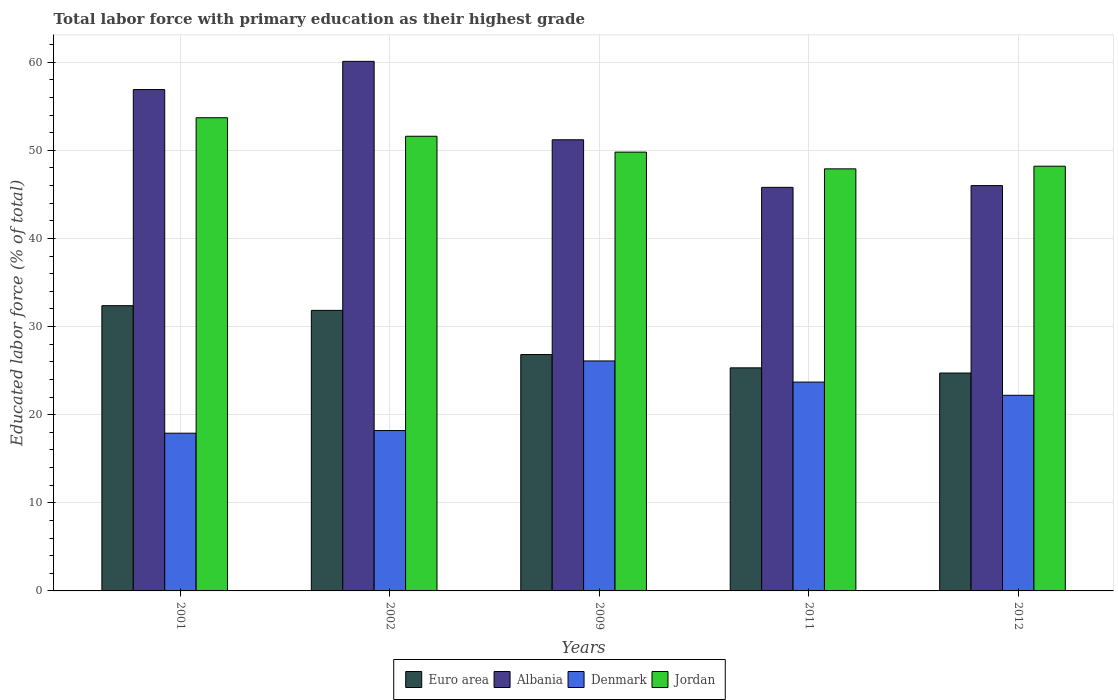How many different coloured bars are there?
Give a very brief answer. 4. How many groups of bars are there?
Your response must be concise. 5. Are the number of bars per tick equal to the number of legend labels?
Make the answer very short. Yes. Are the number of bars on each tick of the X-axis equal?
Provide a short and direct response. Yes. How many bars are there on the 1st tick from the left?
Keep it short and to the point. 4. In how many cases, is the number of bars for a given year not equal to the number of legend labels?
Offer a very short reply. 0. What is the percentage of total labor force with primary education in Albania in 2002?
Your response must be concise. 60.1. Across all years, what is the maximum percentage of total labor force with primary education in Denmark?
Make the answer very short. 26.1. Across all years, what is the minimum percentage of total labor force with primary education in Denmark?
Make the answer very short. 17.9. In which year was the percentage of total labor force with primary education in Euro area maximum?
Provide a succinct answer. 2001. In which year was the percentage of total labor force with primary education in Denmark minimum?
Your answer should be compact. 2001. What is the total percentage of total labor force with primary education in Jordan in the graph?
Offer a very short reply. 251.2. What is the difference between the percentage of total labor force with primary education in Albania in 2001 and that in 2012?
Make the answer very short. 10.9. What is the difference between the percentage of total labor force with primary education in Jordan in 2009 and the percentage of total labor force with primary education in Albania in 2002?
Provide a short and direct response. -10.3. What is the average percentage of total labor force with primary education in Denmark per year?
Offer a very short reply. 21.62. In the year 2011, what is the difference between the percentage of total labor force with primary education in Albania and percentage of total labor force with primary education in Denmark?
Provide a succinct answer. 22.1. What is the ratio of the percentage of total labor force with primary education in Euro area in 2002 to that in 2009?
Offer a terse response. 1.19. What is the difference between the highest and the second highest percentage of total labor force with primary education in Albania?
Your answer should be very brief. 3.2. What is the difference between the highest and the lowest percentage of total labor force with primary education in Albania?
Make the answer very short. 14.3. Is the sum of the percentage of total labor force with primary education in Denmark in 2011 and 2012 greater than the maximum percentage of total labor force with primary education in Euro area across all years?
Your response must be concise. Yes. What does the 2nd bar from the left in 2011 represents?
Ensure brevity in your answer.  Albania. What does the 2nd bar from the right in 2002 represents?
Your response must be concise. Denmark. Are all the bars in the graph horizontal?
Offer a terse response. No. Does the graph contain grids?
Ensure brevity in your answer.  Yes. How are the legend labels stacked?
Keep it short and to the point. Horizontal. What is the title of the graph?
Offer a very short reply. Total labor force with primary education as their highest grade. What is the label or title of the Y-axis?
Your answer should be very brief. Educated labor force (% of total). What is the Educated labor force (% of total) in Euro area in 2001?
Make the answer very short. 32.37. What is the Educated labor force (% of total) in Albania in 2001?
Ensure brevity in your answer.  56.9. What is the Educated labor force (% of total) in Denmark in 2001?
Offer a very short reply. 17.9. What is the Educated labor force (% of total) of Jordan in 2001?
Your answer should be very brief. 53.7. What is the Educated labor force (% of total) of Euro area in 2002?
Make the answer very short. 31.84. What is the Educated labor force (% of total) of Albania in 2002?
Provide a succinct answer. 60.1. What is the Educated labor force (% of total) of Denmark in 2002?
Keep it short and to the point. 18.2. What is the Educated labor force (% of total) in Jordan in 2002?
Ensure brevity in your answer.  51.6. What is the Educated labor force (% of total) in Euro area in 2009?
Give a very brief answer. 26.83. What is the Educated labor force (% of total) of Albania in 2009?
Provide a short and direct response. 51.2. What is the Educated labor force (% of total) in Denmark in 2009?
Ensure brevity in your answer.  26.1. What is the Educated labor force (% of total) of Jordan in 2009?
Provide a succinct answer. 49.8. What is the Educated labor force (% of total) of Euro area in 2011?
Keep it short and to the point. 25.32. What is the Educated labor force (% of total) of Albania in 2011?
Provide a succinct answer. 45.8. What is the Educated labor force (% of total) of Denmark in 2011?
Your answer should be compact. 23.7. What is the Educated labor force (% of total) of Jordan in 2011?
Provide a succinct answer. 47.9. What is the Educated labor force (% of total) of Euro area in 2012?
Make the answer very short. 24.73. What is the Educated labor force (% of total) of Albania in 2012?
Your response must be concise. 46. What is the Educated labor force (% of total) in Denmark in 2012?
Your response must be concise. 22.2. What is the Educated labor force (% of total) of Jordan in 2012?
Provide a short and direct response. 48.2. Across all years, what is the maximum Educated labor force (% of total) in Euro area?
Ensure brevity in your answer.  32.37. Across all years, what is the maximum Educated labor force (% of total) of Albania?
Your answer should be very brief. 60.1. Across all years, what is the maximum Educated labor force (% of total) in Denmark?
Provide a short and direct response. 26.1. Across all years, what is the maximum Educated labor force (% of total) in Jordan?
Ensure brevity in your answer.  53.7. Across all years, what is the minimum Educated labor force (% of total) of Euro area?
Your response must be concise. 24.73. Across all years, what is the minimum Educated labor force (% of total) of Albania?
Make the answer very short. 45.8. Across all years, what is the minimum Educated labor force (% of total) in Denmark?
Provide a succinct answer. 17.9. Across all years, what is the minimum Educated labor force (% of total) of Jordan?
Your response must be concise. 47.9. What is the total Educated labor force (% of total) of Euro area in the graph?
Offer a very short reply. 141.08. What is the total Educated labor force (% of total) in Albania in the graph?
Keep it short and to the point. 260. What is the total Educated labor force (% of total) in Denmark in the graph?
Offer a very short reply. 108.1. What is the total Educated labor force (% of total) of Jordan in the graph?
Your response must be concise. 251.2. What is the difference between the Educated labor force (% of total) in Euro area in 2001 and that in 2002?
Provide a short and direct response. 0.53. What is the difference between the Educated labor force (% of total) of Albania in 2001 and that in 2002?
Your answer should be very brief. -3.2. What is the difference between the Educated labor force (% of total) of Jordan in 2001 and that in 2002?
Offer a terse response. 2.1. What is the difference between the Educated labor force (% of total) in Euro area in 2001 and that in 2009?
Provide a succinct answer. 5.55. What is the difference between the Educated labor force (% of total) in Euro area in 2001 and that in 2011?
Your response must be concise. 7.05. What is the difference between the Educated labor force (% of total) of Denmark in 2001 and that in 2011?
Offer a terse response. -5.8. What is the difference between the Educated labor force (% of total) in Jordan in 2001 and that in 2011?
Offer a terse response. 5.8. What is the difference between the Educated labor force (% of total) in Euro area in 2001 and that in 2012?
Make the answer very short. 7.64. What is the difference between the Educated labor force (% of total) of Denmark in 2001 and that in 2012?
Give a very brief answer. -4.3. What is the difference between the Educated labor force (% of total) of Jordan in 2001 and that in 2012?
Your answer should be compact. 5.5. What is the difference between the Educated labor force (% of total) in Euro area in 2002 and that in 2009?
Give a very brief answer. 5.01. What is the difference between the Educated labor force (% of total) in Denmark in 2002 and that in 2009?
Your answer should be compact. -7.9. What is the difference between the Educated labor force (% of total) in Euro area in 2002 and that in 2011?
Offer a very short reply. 6.52. What is the difference between the Educated labor force (% of total) in Jordan in 2002 and that in 2011?
Keep it short and to the point. 3.7. What is the difference between the Educated labor force (% of total) in Euro area in 2002 and that in 2012?
Provide a short and direct response. 7.11. What is the difference between the Educated labor force (% of total) in Albania in 2002 and that in 2012?
Keep it short and to the point. 14.1. What is the difference between the Educated labor force (% of total) of Euro area in 2009 and that in 2011?
Make the answer very short. 1.51. What is the difference between the Educated labor force (% of total) in Jordan in 2009 and that in 2011?
Your response must be concise. 1.9. What is the difference between the Educated labor force (% of total) in Euro area in 2009 and that in 2012?
Your answer should be very brief. 2.1. What is the difference between the Educated labor force (% of total) of Albania in 2009 and that in 2012?
Your answer should be very brief. 5.2. What is the difference between the Educated labor force (% of total) of Euro area in 2011 and that in 2012?
Your answer should be compact. 0.59. What is the difference between the Educated labor force (% of total) of Albania in 2011 and that in 2012?
Offer a terse response. -0.2. What is the difference between the Educated labor force (% of total) in Denmark in 2011 and that in 2012?
Give a very brief answer. 1.5. What is the difference between the Educated labor force (% of total) in Jordan in 2011 and that in 2012?
Keep it short and to the point. -0.3. What is the difference between the Educated labor force (% of total) of Euro area in 2001 and the Educated labor force (% of total) of Albania in 2002?
Give a very brief answer. -27.73. What is the difference between the Educated labor force (% of total) of Euro area in 2001 and the Educated labor force (% of total) of Denmark in 2002?
Ensure brevity in your answer.  14.17. What is the difference between the Educated labor force (% of total) in Euro area in 2001 and the Educated labor force (% of total) in Jordan in 2002?
Keep it short and to the point. -19.23. What is the difference between the Educated labor force (% of total) of Albania in 2001 and the Educated labor force (% of total) of Denmark in 2002?
Keep it short and to the point. 38.7. What is the difference between the Educated labor force (% of total) in Albania in 2001 and the Educated labor force (% of total) in Jordan in 2002?
Offer a very short reply. 5.3. What is the difference between the Educated labor force (% of total) of Denmark in 2001 and the Educated labor force (% of total) of Jordan in 2002?
Your answer should be very brief. -33.7. What is the difference between the Educated labor force (% of total) of Euro area in 2001 and the Educated labor force (% of total) of Albania in 2009?
Keep it short and to the point. -18.83. What is the difference between the Educated labor force (% of total) in Euro area in 2001 and the Educated labor force (% of total) in Denmark in 2009?
Your response must be concise. 6.27. What is the difference between the Educated labor force (% of total) in Euro area in 2001 and the Educated labor force (% of total) in Jordan in 2009?
Ensure brevity in your answer.  -17.43. What is the difference between the Educated labor force (% of total) in Albania in 2001 and the Educated labor force (% of total) in Denmark in 2009?
Your answer should be compact. 30.8. What is the difference between the Educated labor force (% of total) in Denmark in 2001 and the Educated labor force (% of total) in Jordan in 2009?
Ensure brevity in your answer.  -31.9. What is the difference between the Educated labor force (% of total) of Euro area in 2001 and the Educated labor force (% of total) of Albania in 2011?
Ensure brevity in your answer.  -13.43. What is the difference between the Educated labor force (% of total) of Euro area in 2001 and the Educated labor force (% of total) of Denmark in 2011?
Your answer should be very brief. 8.67. What is the difference between the Educated labor force (% of total) in Euro area in 2001 and the Educated labor force (% of total) in Jordan in 2011?
Give a very brief answer. -15.53. What is the difference between the Educated labor force (% of total) in Albania in 2001 and the Educated labor force (% of total) in Denmark in 2011?
Provide a succinct answer. 33.2. What is the difference between the Educated labor force (% of total) of Albania in 2001 and the Educated labor force (% of total) of Jordan in 2011?
Keep it short and to the point. 9. What is the difference between the Educated labor force (% of total) in Denmark in 2001 and the Educated labor force (% of total) in Jordan in 2011?
Make the answer very short. -30. What is the difference between the Educated labor force (% of total) of Euro area in 2001 and the Educated labor force (% of total) of Albania in 2012?
Provide a succinct answer. -13.63. What is the difference between the Educated labor force (% of total) in Euro area in 2001 and the Educated labor force (% of total) in Denmark in 2012?
Offer a terse response. 10.17. What is the difference between the Educated labor force (% of total) in Euro area in 2001 and the Educated labor force (% of total) in Jordan in 2012?
Ensure brevity in your answer.  -15.83. What is the difference between the Educated labor force (% of total) of Albania in 2001 and the Educated labor force (% of total) of Denmark in 2012?
Make the answer very short. 34.7. What is the difference between the Educated labor force (% of total) in Albania in 2001 and the Educated labor force (% of total) in Jordan in 2012?
Offer a terse response. 8.7. What is the difference between the Educated labor force (% of total) in Denmark in 2001 and the Educated labor force (% of total) in Jordan in 2012?
Keep it short and to the point. -30.3. What is the difference between the Educated labor force (% of total) in Euro area in 2002 and the Educated labor force (% of total) in Albania in 2009?
Offer a terse response. -19.36. What is the difference between the Educated labor force (% of total) of Euro area in 2002 and the Educated labor force (% of total) of Denmark in 2009?
Your answer should be very brief. 5.74. What is the difference between the Educated labor force (% of total) of Euro area in 2002 and the Educated labor force (% of total) of Jordan in 2009?
Offer a very short reply. -17.96. What is the difference between the Educated labor force (% of total) in Albania in 2002 and the Educated labor force (% of total) in Denmark in 2009?
Provide a succinct answer. 34. What is the difference between the Educated labor force (% of total) of Albania in 2002 and the Educated labor force (% of total) of Jordan in 2009?
Give a very brief answer. 10.3. What is the difference between the Educated labor force (% of total) in Denmark in 2002 and the Educated labor force (% of total) in Jordan in 2009?
Offer a terse response. -31.6. What is the difference between the Educated labor force (% of total) of Euro area in 2002 and the Educated labor force (% of total) of Albania in 2011?
Make the answer very short. -13.96. What is the difference between the Educated labor force (% of total) of Euro area in 2002 and the Educated labor force (% of total) of Denmark in 2011?
Make the answer very short. 8.14. What is the difference between the Educated labor force (% of total) of Euro area in 2002 and the Educated labor force (% of total) of Jordan in 2011?
Your answer should be compact. -16.06. What is the difference between the Educated labor force (% of total) of Albania in 2002 and the Educated labor force (% of total) of Denmark in 2011?
Ensure brevity in your answer.  36.4. What is the difference between the Educated labor force (% of total) of Denmark in 2002 and the Educated labor force (% of total) of Jordan in 2011?
Ensure brevity in your answer.  -29.7. What is the difference between the Educated labor force (% of total) of Euro area in 2002 and the Educated labor force (% of total) of Albania in 2012?
Your answer should be compact. -14.16. What is the difference between the Educated labor force (% of total) of Euro area in 2002 and the Educated labor force (% of total) of Denmark in 2012?
Your answer should be compact. 9.64. What is the difference between the Educated labor force (% of total) of Euro area in 2002 and the Educated labor force (% of total) of Jordan in 2012?
Offer a terse response. -16.36. What is the difference between the Educated labor force (% of total) in Albania in 2002 and the Educated labor force (% of total) in Denmark in 2012?
Ensure brevity in your answer.  37.9. What is the difference between the Educated labor force (% of total) in Albania in 2002 and the Educated labor force (% of total) in Jordan in 2012?
Give a very brief answer. 11.9. What is the difference between the Educated labor force (% of total) of Euro area in 2009 and the Educated labor force (% of total) of Albania in 2011?
Offer a terse response. -18.97. What is the difference between the Educated labor force (% of total) of Euro area in 2009 and the Educated labor force (% of total) of Denmark in 2011?
Ensure brevity in your answer.  3.13. What is the difference between the Educated labor force (% of total) of Euro area in 2009 and the Educated labor force (% of total) of Jordan in 2011?
Offer a terse response. -21.07. What is the difference between the Educated labor force (% of total) in Albania in 2009 and the Educated labor force (% of total) in Jordan in 2011?
Your answer should be compact. 3.3. What is the difference between the Educated labor force (% of total) in Denmark in 2009 and the Educated labor force (% of total) in Jordan in 2011?
Give a very brief answer. -21.8. What is the difference between the Educated labor force (% of total) in Euro area in 2009 and the Educated labor force (% of total) in Albania in 2012?
Offer a very short reply. -19.17. What is the difference between the Educated labor force (% of total) in Euro area in 2009 and the Educated labor force (% of total) in Denmark in 2012?
Your answer should be very brief. 4.63. What is the difference between the Educated labor force (% of total) of Euro area in 2009 and the Educated labor force (% of total) of Jordan in 2012?
Provide a succinct answer. -21.37. What is the difference between the Educated labor force (% of total) of Albania in 2009 and the Educated labor force (% of total) of Jordan in 2012?
Ensure brevity in your answer.  3. What is the difference between the Educated labor force (% of total) in Denmark in 2009 and the Educated labor force (% of total) in Jordan in 2012?
Your answer should be compact. -22.1. What is the difference between the Educated labor force (% of total) of Euro area in 2011 and the Educated labor force (% of total) of Albania in 2012?
Give a very brief answer. -20.68. What is the difference between the Educated labor force (% of total) of Euro area in 2011 and the Educated labor force (% of total) of Denmark in 2012?
Your answer should be compact. 3.12. What is the difference between the Educated labor force (% of total) in Euro area in 2011 and the Educated labor force (% of total) in Jordan in 2012?
Offer a very short reply. -22.88. What is the difference between the Educated labor force (% of total) of Albania in 2011 and the Educated labor force (% of total) of Denmark in 2012?
Ensure brevity in your answer.  23.6. What is the difference between the Educated labor force (% of total) in Albania in 2011 and the Educated labor force (% of total) in Jordan in 2012?
Ensure brevity in your answer.  -2.4. What is the difference between the Educated labor force (% of total) in Denmark in 2011 and the Educated labor force (% of total) in Jordan in 2012?
Give a very brief answer. -24.5. What is the average Educated labor force (% of total) in Euro area per year?
Keep it short and to the point. 28.22. What is the average Educated labor force (% of total) in Albania per year?
Provide a short and direct response. 52. What is the average Educated labor force (% of total) of Denmark per year?
Your answer should be very brief. 21.62. What is the average Educated labor force (% of total) in Jordan per year?
Make the answer very short. 50.24. In the year 2001, what is the difference between the Educated labor force (% of total) of Euro area and Educated labor force (% of total) of Albania?
Your answer should be very brief. -24.53. In the year 2001, what is the difference between the Educated labor force (% of total) of Euro area and Educated labor force (% of total) of Denmark?
Your answer should be compact. 14.47. In the year 2001, what is the difference between the Educated labor force (% of total) of Euro area and Educated labor force (% of total) of Jordan?
Your answer should be compact. -21.33. In the year 2001, what is the difference between the Educated labor force (% of total) of Denmark and Educated labor force (% of total) of Jordan?
Keep it short and to the point. -35.8. In the year 2002, what is the difference between the Educated labor force (% of total) of Euro area and Educated labor force (% of total) of Albania?
Provide a short and direct response. -28.26. In the year 2002, what is the difference between the Educated labor force (% of total) of Euro area and Educated labor force (% of total) of Denmark?
Make the answer very short. 13.64. In the year 2002, what is the difference between the Educated labor force (% of total) of Euro area and Educated labor force (% of total) of Jordan?
Keep it short and to the point. -19.76. In the year 2002, what is the difference between the Educated labor force (% of total) of Albania and Educated labor force (% of total) of Denmark?
Your response must be concise. 41.9. In the year 2002, what is the difference between the Educated labor force (% of total) of Albania and Educated labor force (% of total) of Jordan?
Make the answer very short. 8.5. In the year 2002, what is the difference between the Educated labor force (% of total) of Denmark and Educated labor force (% of total) of Jordan?
Offer a terse response. -33.4. In the year 2009, what is the difference between the Educated labor force (% of total) of Euro area and Educated labor force (% of total) of Albania?
Your response must be concise. -24.37. In the year 2009, what is the difference between the Educated labor force (% of total) of Euro area and Educated labor force (% of total) of Denmark?
Provide a short and direct response. 0.73. In the year 2009, what is the difference between the Educated labor force (% of total) of Euro area and Educated labor force (% of total) of Jordan?
Provide a succinct answer. -22.97. In the year 2009, what is the difference between the Educated labor force (% of total) of Albania and Educated labor force (% of total) of Denmark?
Ensure brevity in your answer.  25.1. In the year 2009, what is the difference between the Educated labor force (% of total) of Albania and Educated labor force (% of total) of Jordan?
Keep it short and to the point. 1.4. In the year 2009, what is the difference between the Educated labor force (% of total) of Denmark and Educated labor force (% of total) of Jordan?
Your answer should be very brief. -23.7. In the year 2011, what is the difference between the Educated labor force (% of total) in Euro area and Educated labor force (% of total) in Albania?
Provide a short and direct response. -20.48. In the year 2011, what is the difference between the Educated labor force (% of total) in Euro area and Educated labor force (% of total) in Denmark?
Make the answer very short. 1.62. In the year 2011, what is the difference between the Educated labor force (% of total) in Euro area and Educated labor force (% of total) in Jordan?
Provide a short and direct response. -22.58. In the year 2011, what is the difference between the Educated labor force (% of total) in Albania and Educated labor force (% of total) in Denmark?
Provide a short and direct response. 22.1. In the year 2011, what is the difference between the Educated labor force (% of total) of Albania and Educated labor force (% of total) of Jordan?
Offer a terse response. -2.1. In the year 2011, what is the difference between the Educated labor force (% of total) in Denmark and Educated labor force (% of total) in Jordan?
Your response must be concise. -24.2. In the year 2012, what is the difference between the Educated labor force (% of total) in Euro area and Educated labor force (% of total) in Albania?
Ensure brevity in your answer.  -21.27. In the year 2012, what is the difference between the Educated labor force (% of total) of Euro area and Educated labor force (% of total) of Denmark?
Offer a very short reply. 2.53. In the year 2012, what is the difference between the Educated labor force (% of total) in Euro area and Educated labor force (% of total) in Jordan?
Give a very brief answer. -23.47. In the year 2012, what is the difference between the Educated labor force (% of total) in Albania and Educated labor force (% of total) in Denmark?
Offer a terse response. 23.8. In the year 2012, what is the difference between the Educated labor force (% of total) in Albania and Educated labor force (% of total) in Jordan?
Offer a very short reply. -2.2. In the year 2012, what is the difference between the Educated labor force (% of total) of Denmark and Educated labor force (% of total) of Jordan?
Give a very brief answer. -26. What is the ratio of the Educated labor force (% of total) of Euro area in 2001 to that in 2002?
Provide a succinct answer. 1.02. What is the ratio of the Educated labor force (% of total) in Albania in 2001 to that in 2002?
Offer a terse response. 0.95. What is the ratio of the Educated labor force (% of total) in Denmark in 2001 to that in 2002?
Provide a short and direct response. 0.98. What is the ratio of the Educated labor force (% of total) in Jordan in 2001 to that in 2002?
Provide a succinct answer. 1.04. What is the ratio of the Educated labor force (% of total) in Euro area in 2001 to that in 2009?
Offer a very short reply. 1.21. What is the ratio of the Educated labor force (% of total) of Albania in 2001 to that in 2009?
Provide a succinct answer. 1.11. What is the ratio of the Educated labor force (% of total) of Denmark in 2001 to that in 2009?
Offer a very short reply. 0.69. What is the ratio of the Educated labor force (% of total) in Jordan in 2001 to that in 2009?
Offer a terse response. 1.08. What is the ratio of the Educated labor force (% of total) of Euro area in 2001 to that in 2011?
Keep it short and to the point. 1.28. What is the ratio of the Educated labor force (% of total) in Albania in 2001 to that in 2011?
Offer a very short reply. 1.24. What is the ratio of the Educated labor force (% of total) in Denmark in 2001 to that in 2011?
Provide a succinct answer. 0.76. What is the ratio of the Educated labor force (% of total) in Jordan in 2001 to that in 2011?
Ensure brevity in your answer.  1.12. What is the ratio of the Educated labor force (% of total) of Euro area in 2001 to that in 2012?
Ensure brevity in your answer.  1.31. What is the ratio of the Educated labor force (% of total) in Albania in 2001 to that in 2012?
Provide a succinct answer. 1.24. What is the ratio of the Educated labor force (% of total) in Denmark in 2001 to that in 2012?
Keep it short and to the point. 0.81. What is the ratio of the Educated labor force (% of total) in Jordan in 2001 to that in 2012?
Provide a short and direct response. 1.11. What is the ratio of the Educated labor force (% of total) of Euro area in 2002 to that in 2009?
Offer a very short reply. 1.19. What is the ratio of the Educated labor force (% of total) in Albania in 2002 to that in 2009?
Ensure brevity in your answer.  1.17. What is the ratio of the Educated labor force (% of total) in Denmark in 2002 to that in 2009?
Your answer should be compact. 0.7. What is the ratio of the Educated labor force (% of total) in Jordan in 2002 to that in 2009?
Provide a short and direct response. 1.04. What is the ratio of the Educated labor force (% of total) in Euro area in 2002 to that in 2011?
Your response must be concise. 1.26. What is the ratio of the Educated labor force (% of total) in Albania in 2002 to that in 2011?
Give a very brief answer. 1.31. What is the ratio of the Educated labor force (% of total) in Denmark in 2002 to that in 2011?
Keep it short and to the point. 0.77. What is the ratio of the Educated labor force (% of total) of Jordan in 2002 to that in 2011?
Offer a terse response. 1.08. What is the ratio of the Educated labor force (% of total) in Euro area in 2002 to that in 2012?
Offer a very short reply. 1.29. What is the ratio of the Educated labor force (% of total) in Albania in 2002 to that in 2012?
Offer a very short reply. 1.31. What is the ratio of the Educated labor force (% of total) of Denmark in 2002 to that in 2012?
Your answer should be very brief. 0.82. What is the ratio of the Educated labor force (% of total) in Jordan in 2002 to that in 2012?
Give a very brief answer. 1.07. What is the ratio of the Educated labor force (% of total) in Euro area in 2009 to that in 2011?
Your answer should be very brief. 1.06. What is the ratio of the Educated labor force (% of total) in Albania in 2009 to that in 2011?
Provide a succinct answer. 1.12. What is the ratio of the Educated labor force (% of total) of Denmark in 2009 to that in 2011?
Provide a short and direct response. 1.1. What is the ratio of the Educated labor force (% of total) in Jordan in 2009 to that in 2011?
Offer a terse response. 1.04. What is the ratio of the Educated labor force (% of total) in Euro area in 2009 to that in 2012?
Your answer should be compact. 1.08. What is the ratio of the Educated labor force (% of total) in Albania in 2009 to that in 2012?
Offer a very short reply. 1.11. What is the ratio of the Educated labor force (% of total) of Denmark in 2009 to that in 2012?
Give a very brief answer. 1.18. What is the ratio of the Educated labor force (% of total) in Jordan in 2009 to that in 2012?
Make the answer very short. 1.03. What is the ratio of the Educated labor force (% of total) of Euro area in 2011 to that in 2012?
Your answer should be compact. 1.02. What is the ratio of the Educated labor force (% of total) of Denmark in 2011 to that in 2012?
Your answer should be compact. 1.07. What is the ratio of the Educated labor force (% of total) in Jordan in 2011 to that in 2012?
Ensure brevity in your answer.  0.99. What is the difference between the highest and the second highest Educated labor force (% of total) in Euro area?
Provide a short and direct response. 0.53. What is the difference between the highest and the second highest Educated labor force (% of total) in Denmark?
Give a very brief answer. 2.4. What is the difference between the highest and the second highest Educated labor force (% of total) in Jordan?
Give a very brief answer. 2.1. What is the difference between the highest and the lowest Educated labor force (% of total) of Euro area?
Your answer should be very brief. 7.64. What is the difference between the highest and the lowest Educated labor force (% of total) of Jordan?
Offer a terse response. 5.8. 